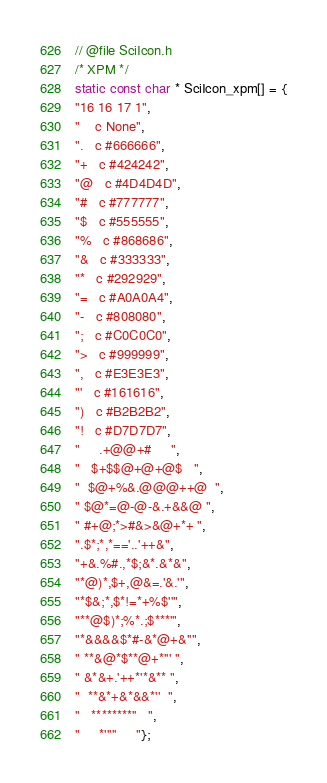<code> <loc_0><loc_0><loc_500><loc_500><_C_>// @file SciIcon.h
/* XPM */
static const char * SciIcon_xpm[] = {
"16 16 17 1",
" 	c None",
".	c #666666",
"+	c #424242",
"@	c #4D4D4D",
"#	c #777777",
"$	c #555555",
"%	c #868686",
"&	c #333333",
"*	c #292929",
"=	c #A0A0A4",
"-	c #808080",
";	c #C0C0C0",
">	c #999999",
",	c #E3E3E3",
"'	c #161616",
")	c #B2B2B2",
"!	c #D7D7D7",
"     .+@@+#     ",
"   $+$$@+@+@$   ",
"  $@+%&.@@@++@  ",
" $@*=@-@-&.+&&@ ",
" #+@;*>#&>&@+*+ ",
".$*;*,*=='..'++&",
"+&.%#.,*$;&*.&*&",
"*@)*,$+,@&=.'&.'",
"*$&;*,$*!=*+%$''",
"**@$)*;%*.;$***'",
"*&&&&$*#-&*@+&''",
" **&@*$**@+*''' ",
" &*&+.'++*'*&** ",
"  **&*+&*&&*''  ",
"   ********''   ",
"     *'''''     "};
</code> 